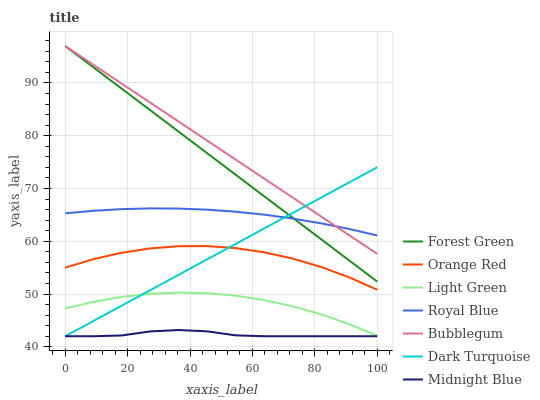Does Midnight Blue have the minimum area under the curve?
Answer yes or no. Yes. Does Bubblegum have the maximum area under the curve?
Answer yes or no. Yes. Does Dark Turquoise have the minimum area under the curve?
Answer yes or no. No. Does Dark Turquoise have the maximum area under the curve?
Answer yes or no. No. Is Forest Green the smoothest?
Answer yes or no. Yes. Is Orange Red the roughest?
Answer yes or no. Yes. Is Dark Turquoise the smoothest?
Answer yes or no. No. Is Dark Turquoise the roughest?
Answer yes or no. No. Does Midnight Blue have the lowest value?
Answer yes or no. Yes. Does Bubblegum have the lowest value?
Answer yes or no. No. Does Forest Green have the highest value?
Answer yes or no. Yes. Does Dark Turquoise have the highest value?
Answer yes or no. No. Is Midnight Blue less than Bubblegum?
Answer yes or no. Yes. Is Bubblegum greater than Midnight Blue?
Answer yes or no. Yes. Does Light Green intersect Dark Turquoise?
Answer yes or no. Yes. Is Light Green less than Dark Turquoise?
Answer yes or no. No. Is Light Green greater than Dark Turquoise?
Answer yes or no. No. Does Midnight Blue intersect Bubblegum?
Answer yes or no. No. 